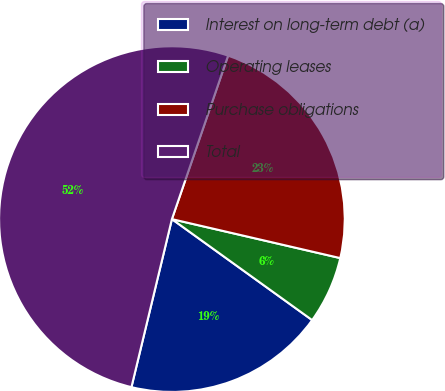<chart> <loc_0><loc_0><loc_500><loc_500><pie_chart><fcel>Interest on long-term debt (a)<fcel>Operating leases<fcel>Purchase obligations<fcel>Total<nl><fcel>18.83%<fcel>6.31%<fcel>23.35%<fcel>51.51%<nl></chart> 